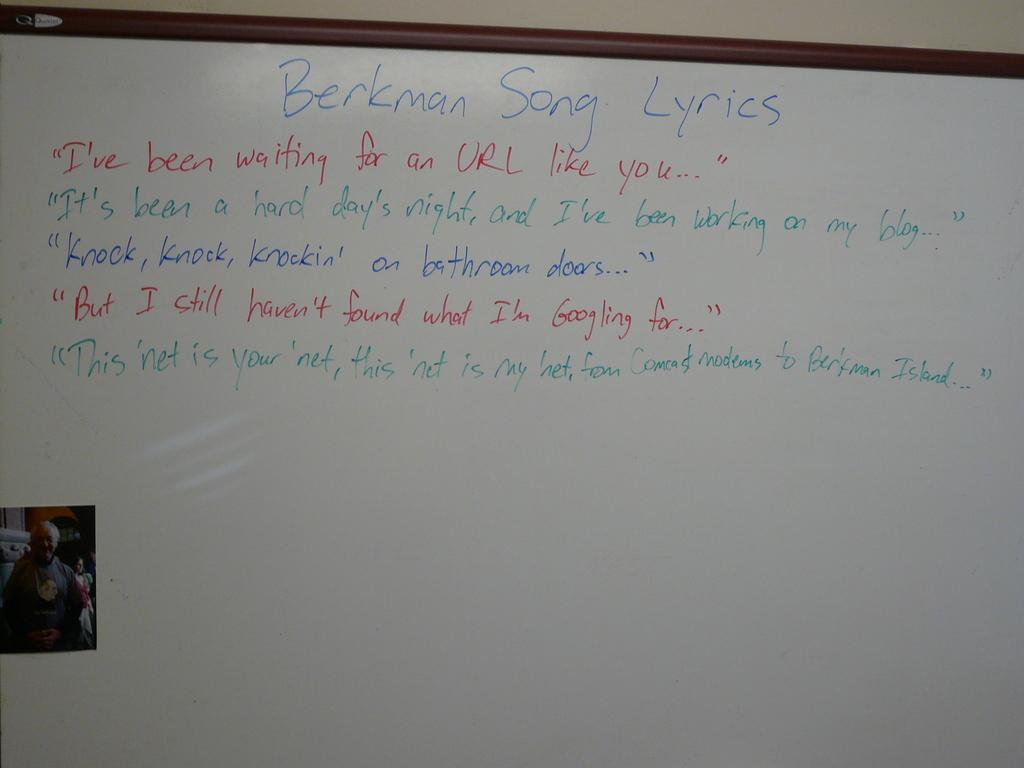What is the title of this list?
Offer a terse response. Berkman song lyrics. What have they been waiting for?
Give a very brief answer. Url like you. 